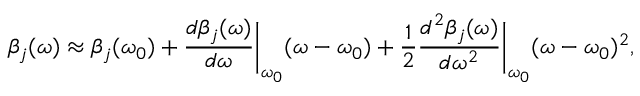Convert formula to latex. <formula><loc_0><loc_0><loc_500><loc_500>\beta _ { j } ( \omega ) \approx \beta _ { j } ( \omega _ { 0 } ) + \frac { d \beta _ { j } ( \omega ) } { d \omega } \left | _ { \omega _ { 0 } } ( \omega - \omega _ { 0 } ) + \frac { 1 } { 2 } \frac { d ^ { 2 } \beta _ { j } ( \omega ) } { d \omega ^ { 2 } } \right | _ { \omega _ { 0 } } ( \omega - \omega _ { 0 } ) ^ { 2 } ,</formula> 